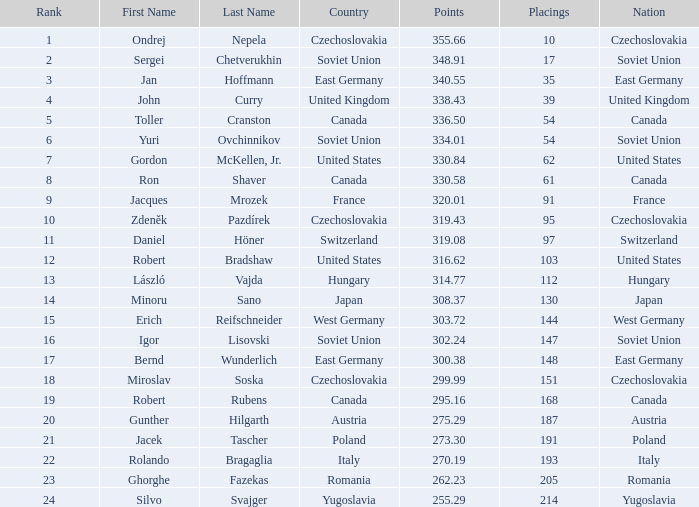Which Nation has Points of 300.38? East Germany. 